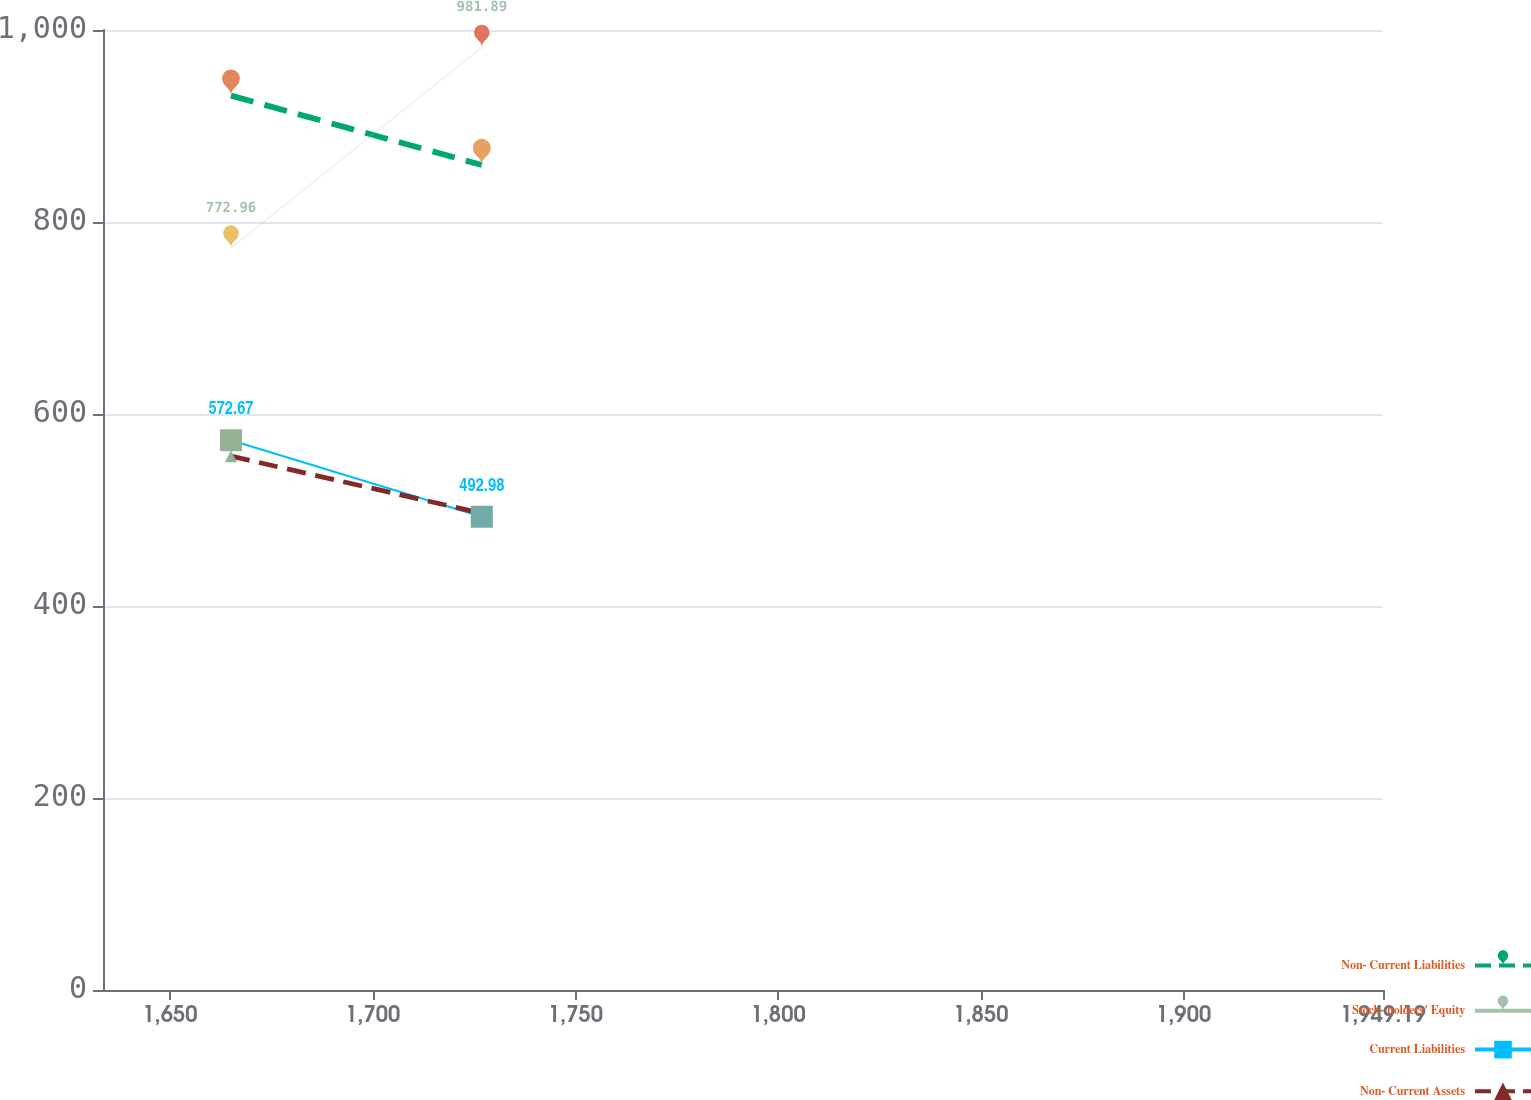Convert chart to OTSL. <chart><loc_0><loc_0><loc_500><loc_500><line_chart><ecel><fcel>Non- Current Liabilities<fcel>Stock- holders' Equity<fcel>Current Liabilities<fcel>Non- Current Assets<nl><fcel>1665.06<fcel>931.67<fcel>772.96<fcel>572.67<fcel>556.09<nl><fcel>1726.92<fcel>859.34<fcel>981.89<fcel>492.98<fcel>496.57<nl><fcel>1980.76<fcel>976.1<fcel>1088.69<fcel>422.9<fcel>550.36<nl></chart> 